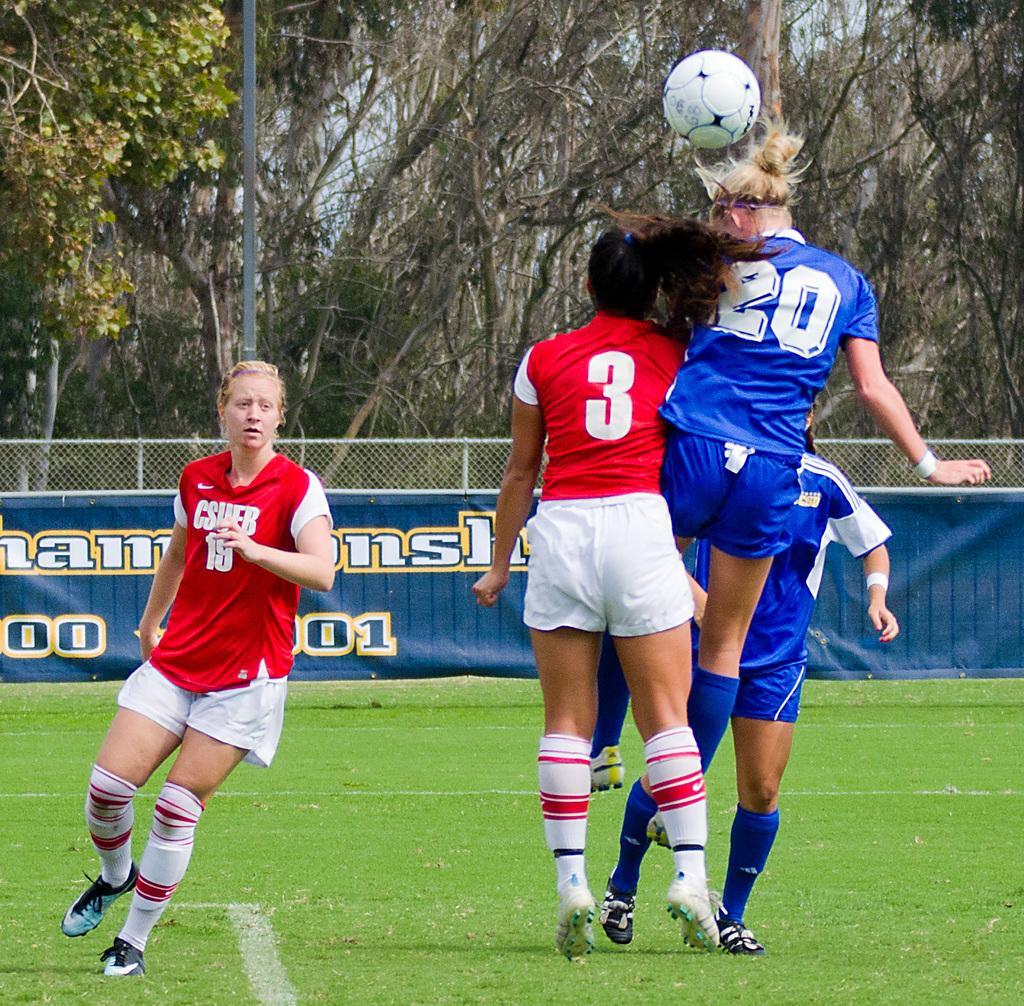Could you give a brief overview of what you see in this image? In this picture we can see trees, and here is the pole and at the beneath here is the fencing, and here is the ground and the person is running, and the group of persons is jumping, and at the above there is the ball. 